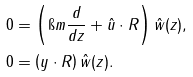Convert formula to latex. <formula><loc_0><loc_0><loc_500><loc_500>0 & = \left ( \i m \frac { d } { d z } + \hat { u } \cdot R \right ) \hat { w } ( z ) , \\ 0 & = \left ( y \cdot R \right ) \hat { w } ( z ) .</formula> 